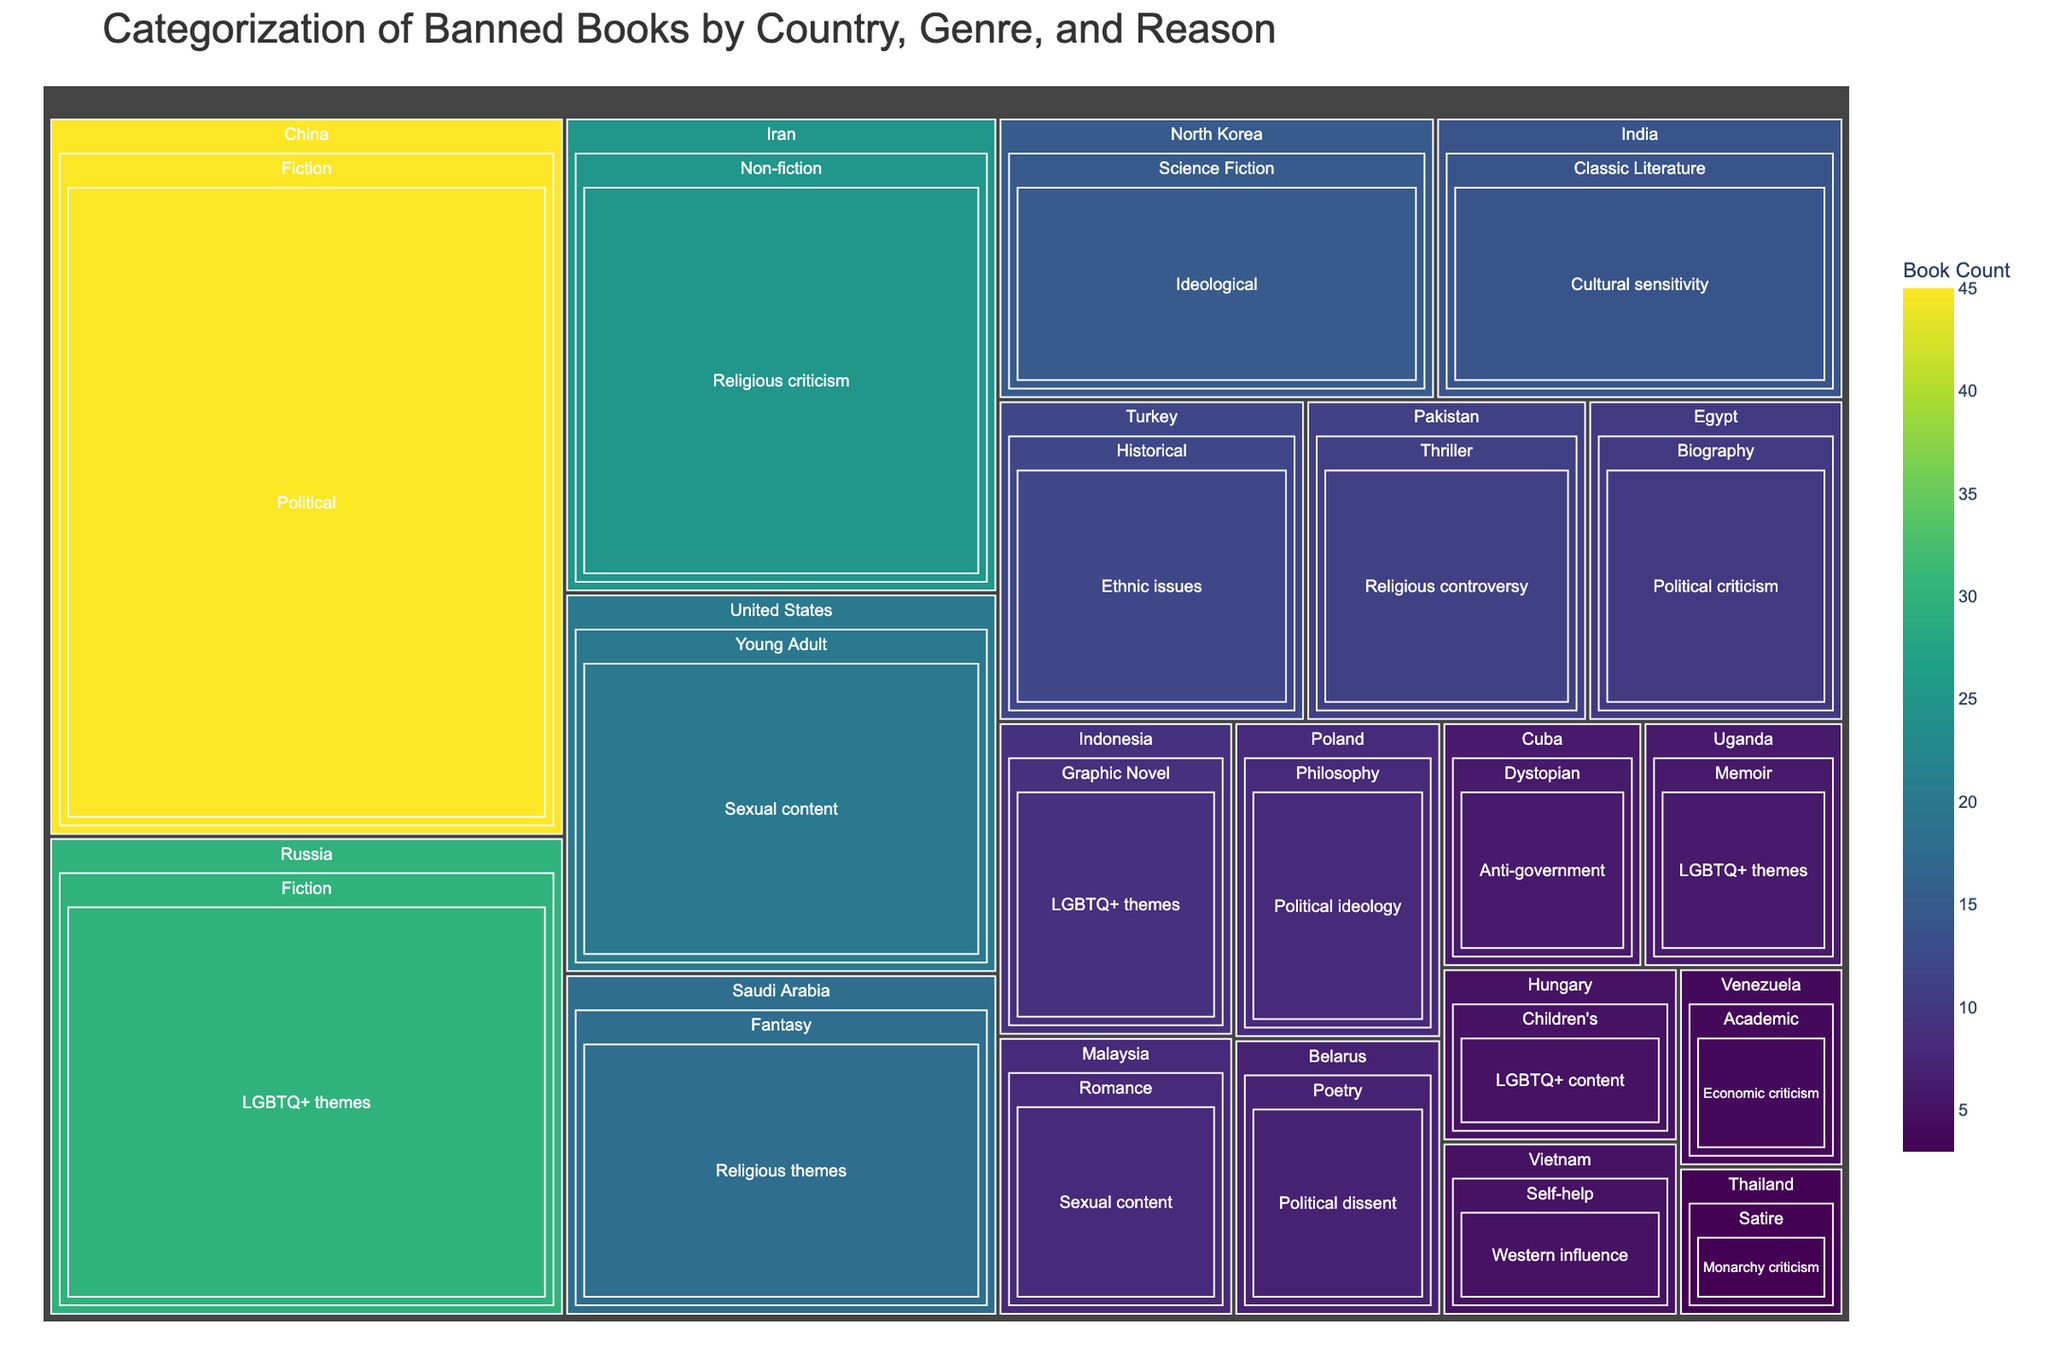What's the title of the Treemap? The title is displayed at the top of the figure and summarizes the main theme.
Answer: Categorization of Banned Books by Country, Genre, and Reason Which genre has the highest number of banned books for political reasons in China? Locate the 'China' branch in the treemap, then find the 'Fiction' branch under it and count the sub-branch labeled 'Political'.
Answer: Fiction What is the combined count of banned LGBTQ+ themed books in Russia and Indonesia? Identify branches for Russia and Indonesia, sum up the 'LGBTQ+ themes' counts: 30 (Russia) + 9 (Indonesia).
Answer: 39 Which country has the most banned books related to sexual content? Locate 'Sexual content' branches under each country, the highest number (United States) has 20.
Answer: United States How many countries have at least one banned book due to LGBTQ+ themes or content? Check each country node’s branches to count those having 'LGBTQ+ themes' or 'LGBTQ+ content'. Countries are Russia, Indonesia, Uganda, and Hungary.
Answer: 4 By what margin does the count of Fiction genre banned books in China exceed the Fantasy genre banned books in Saudi Arabia? Identify the counts: Fiction in China (45) and Fantasy in Saudi Arabia (18). Calculate the difference: 45 - 18.
Answer: 27 Which country has the lowest count, and what is the genre and reason? Find the smallest count, which is under Thailand for 'Satire' with reason 'Monarchy criticism'.
Answer: Thailand, Satire, Monarchy criticism Are there more banned books attributed to political reasons in China or to religious themes in Saudi Arabia? Compare the counts: Political in China (45) with Religious themes in Saudi Arabia (18).
Answer: China What is the total number of banned children's books? Locate and sum the 'Children's' branch: Hungary has 5.
Answer: 5 Which genres have banned books due to religious reasons and in which countries? Locate branches with religious reasons: Non-fiction in Iran (Religious criticism), Fantasy in Saudi Arabia (Religious themes), and Thriller in Pakistan (Religious controversy).
Answer: Iran, Saudi Arabia, Pakistan 